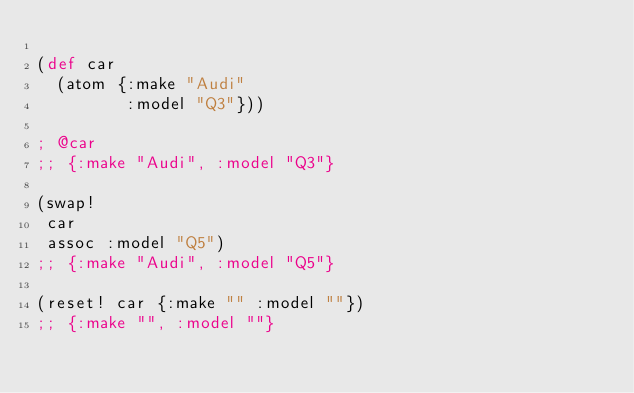Convert code to text. <code><loc_0><loc_0><loc_500><loc_500><_Clojure_>
(def car
  (atom {:make "Audi"
         :model "Q3"}))

; @car
;; {:make "Audi", :model "Q3"}

(swap!
 car
 assoc :model "Q5")
;; {:make "Audi", :model "Q5"}

(reset! car {:make "" :model ""})
;; {:make "", :model ""}
</code> 